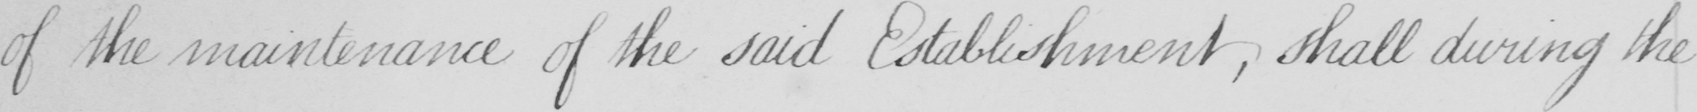Transcribe the text shown in this historical manuscript line. of the maintenance of the said Establishment , shall during the 